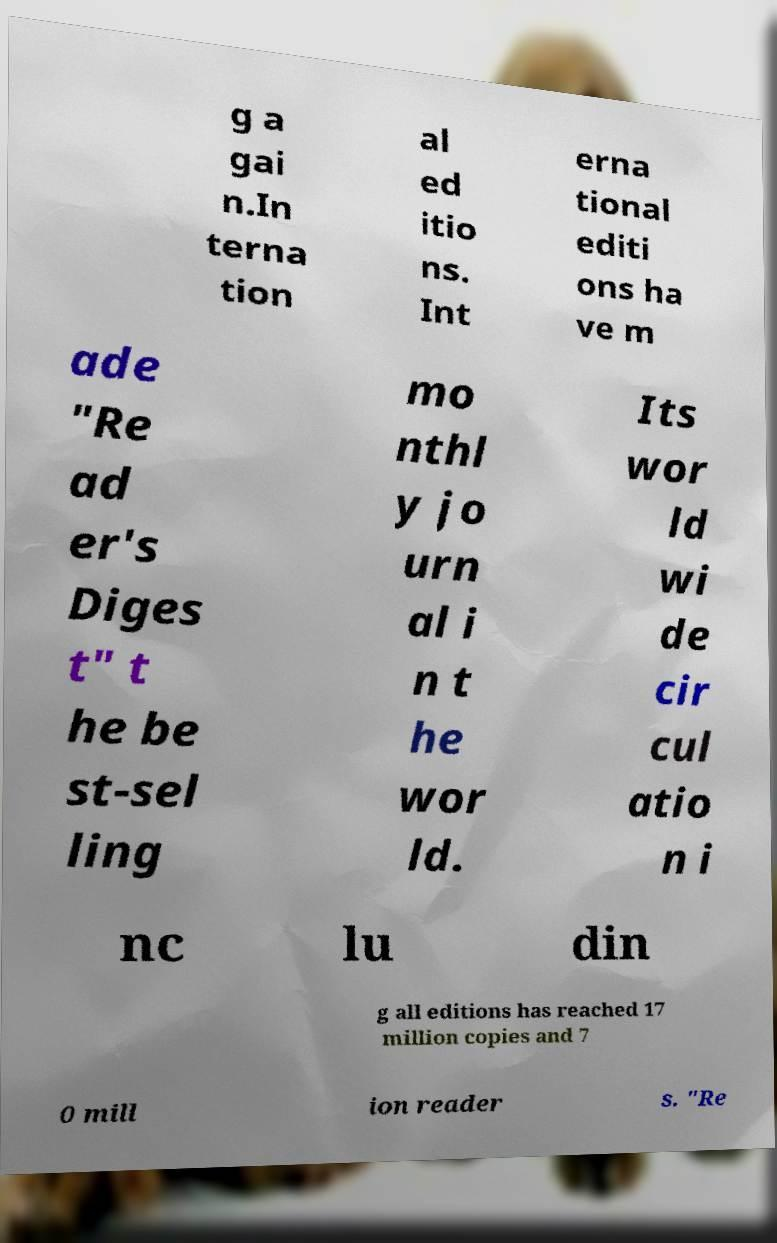For documentation purposes, I need the text within this image transcribed. Could you provide that? g a gai n.In terna tion al ed itio ns. Int erna tional editi ons ha ve m ade "Re ad er's Diges t" t he be st-sel ling mo nthl y jo urn al i n t he wor ld. Its wor ld wi de cir cul atio n i nc lu din g all editions has reached 17 million copies and 7 0 mill ion reader s. "Re 